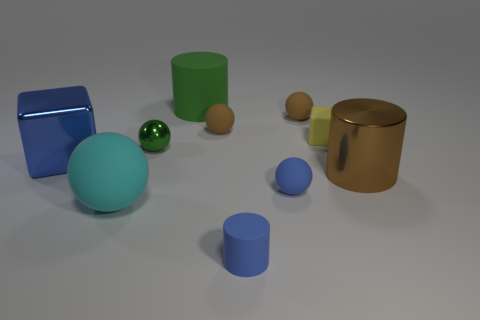Subtract all blue spheres. How many spheres are left? 4 Subtract all gray balls. Subtract all brown cubes. How many balls are left? 5 Subtract all cylinders. How many objects are left? 7 Add 7 large balls. How many large balls are left? 8 Add 5 green things. How many green things exist? 7 Subtract 1 brown cylinders. How many objects are left? 9 Subtract all large objects. Subtract all small blue matte things. How many objects are left? 4 